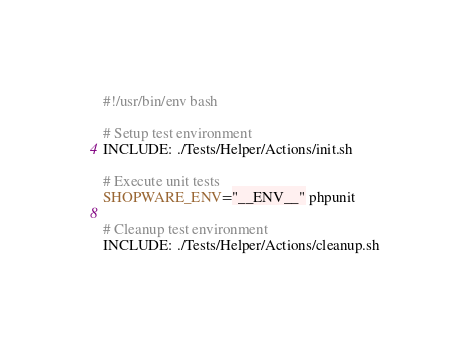<code> <loc_0><loc_0><loc_500><loc_500><_Bash_>#!/usr/bin/env bash

# Setup test environment
INCLUDE: ./Tests/Helper/Actions/init.sh

# Execute unit tests
SHOPWARE_ENV="__ENV__" phpunit

# Cleanup test environment
INCLUDE: ./Tests/Helper/Actions/cleanup.sh
</code> 